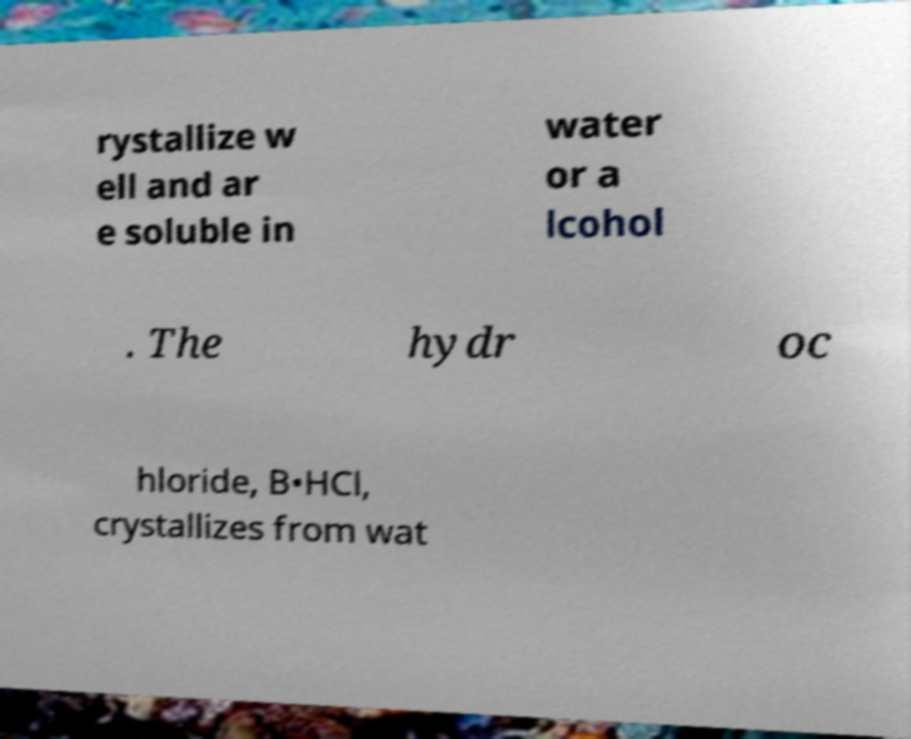For documentation purposes, I need the text within this image transcribed. Could you provide that? rystallize w ell and ar e soluble in water or a lcohol . The hydr oc hloride, B•HCl, crystallizes from wat 